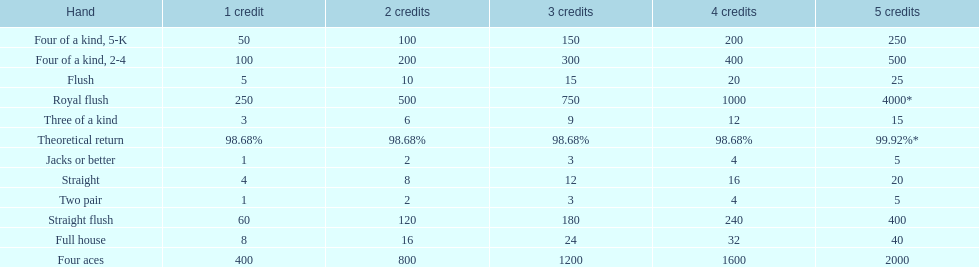After winning on four credits with a full house, what is your payout? 32. 